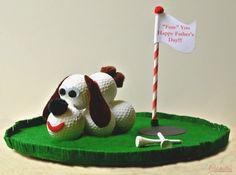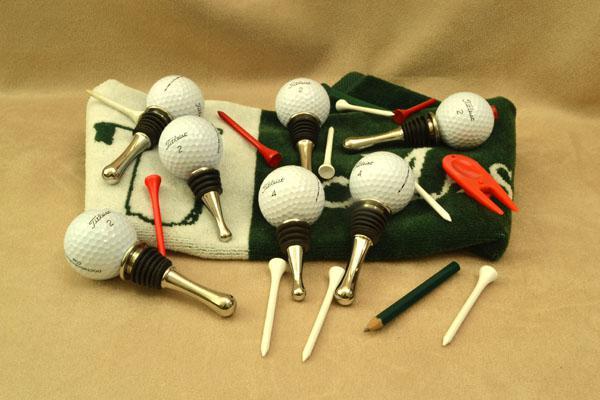The first image is the image on the left, the second image is the image on the right. Given the left and right images, does the statement "Each image includes a dog figure made out of white golf balls with a black tee tail." hold true? Answer yes or no. No. The first image is the image on the left, the second image is the image on the right. Analyze the images presented: Is the assertion "All the golf balls are white." valid? Answer yes or no. Yes. 